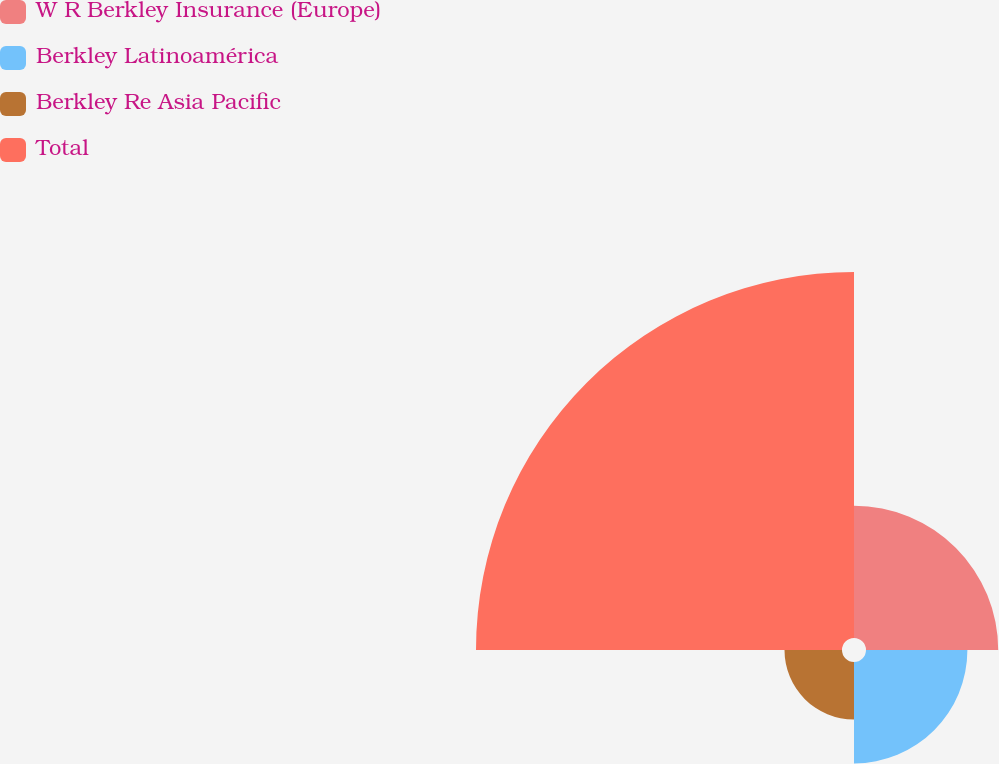Convert chart to OTSL. <chart><loc_0><loc_0><loc_500><loc_500><pie_chart><fcel>W R Berkley Insurance (Europe)<fcel>Berkley Latinoamérica<fcel>Berkley Re Asia Pacific<fcel>Total<nl><fcel>20.12%<fcel>15.43%<fcel>8.75%<fcel>55.7%<nl></chart> 